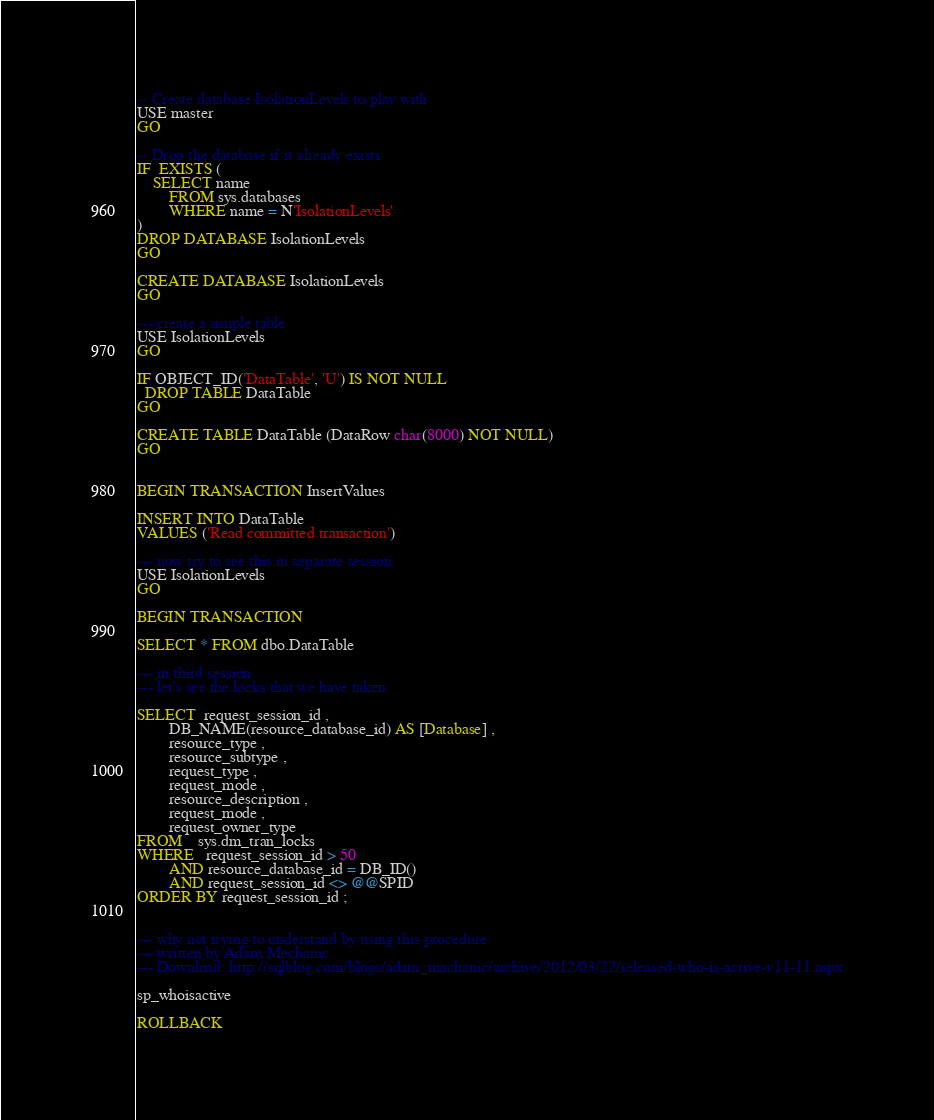<code> <loc_0><loc_0><loc_500><loc_500><_SQL_>

-- Create database IsolationLevels to play with
USE master
GO

-- Drop the database if it already exists
IF  EXISTS (
	SELECT name 
		FROM sys.databases 
		WHERE name = N'IsolationLevels'
)
DROP DATABASE IsolationLevels
GO

CREATE DATABASE IsolationLevels
GO

--- create a simple table
USE IsolationLevels
GO

IF OBJECT_ID('DataTable', 'U') IS NOT NULL
  DROP TABLE DataTable
GO

CREATE TABLE DataTable (DataRow char(8000) NOT NULL)
GO


BEGIN TRANSACTION InsertValues 

INSERT INTO DataTable
VALUES ('Read committed transaction')

--- now try to see this in separate session
USE IsolationLevels
GO

BEGIN TRANSACTION

SELECT * FROM dbo.DataTable

--- in third session
--- let's see the locks that we have taken

SELECT  request_session_id ,
        DB_NAME(resource_database_id) AS [Database] ,
        resource_type ,
        resource_subtype ,
        request_type ,
        request_mode ,
        resource_description ,
        request_mode ,
        request_owner_type
FROM    sys.dm_tran_locks
WHERE   request_session_id > 50
        AND resource_database_id = DB_ID()
        AND request_session_id <> @@SPID
ORDER BY request_session_id ;


--- why not trying to understand by using this procedure
--- written by Adam Mechanic
--- Download: http://sqlblog.com/blogs/adam_machanic/archive/2012/03/22/released-who-is-active-v11-11.aspx

sp_whoisactive

ROLLBACK
</code> 